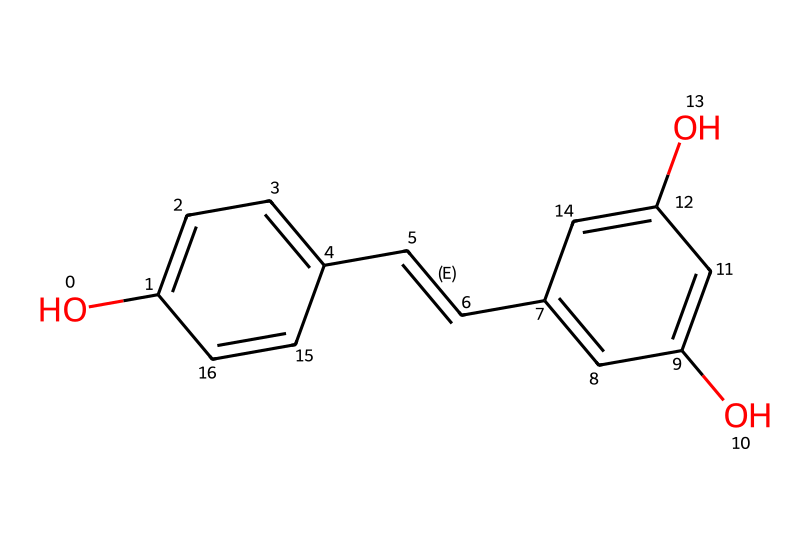What is the molecular formula of resveratrol? By analyzing the SMILES representation, we can count the atoms represented. The molecular formula can be deduced as C14H12O3 from the structure indicated in the SMILES.
Answer: C14H12O3 How many hydroxyl (–OH) groups are present in resveratrol? Looking at the SMILES, we can see two instances where hydroxyl (–OH) groups are attached to the aromatic rings, indicating the presence of two –OH functional groups.
Answer: 2 How many double bonds are present in resveratrol? A closer inspection of the SMILES shows one double bond in the side chain connecting the two aromatic rings and another one between the carbon atoms in the chain of the first aromatic part. Therefore, there are two double bonds.
Answer: 2 Which functional groups are present in resveratrol? By examining the structure in the SMILES representation, we identify hydroxyl groups (–OH) and an alkene group (C=C), indicating the presence of these functional groups.
Answer: hydroxyl and alkene What type of chemical is resveratrol? Considering its structure comprising aromatic rings with hydroxyl groups, it classifies as a phenolic compound, a hallmark characteristic of phenols.
Answer: phenolic What does the presence of multiple hydroxyl groups in resveratrol suggest about its solubility? The presence of multiple hydroxyl groups enhances its polar nature, leading to better solubility in polar solvents such as water due to hydrogen bonding, characteristic of many phenols.
Answer: high solubility What is the significance of resveratrol's structure in relation to its biological activity? Resveratrol's structure, particularly with multiple –OH groups and conjugated double bonds, contributes to antioxidant properties and interactions with various biological pathways, reflecting its significant bioactivity.
Answer: antioxidant properties 